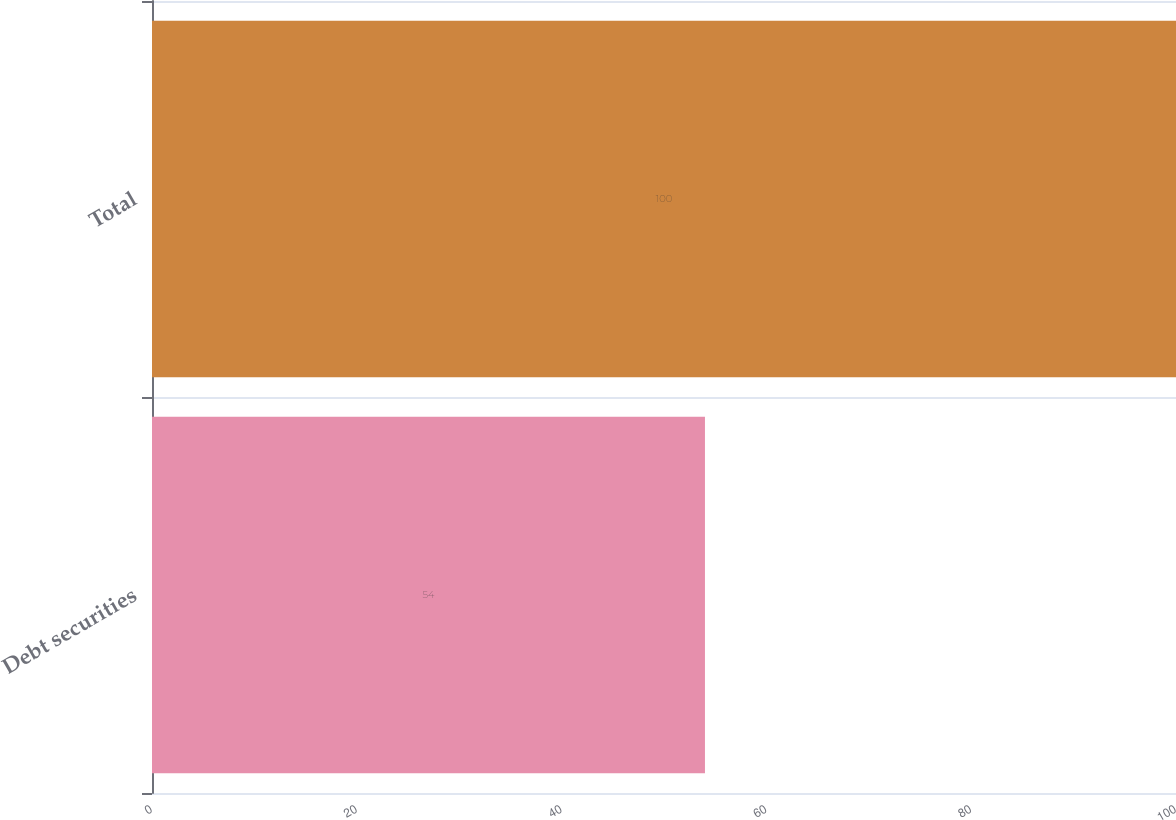<chart> <loc_0><loc_0><loc_500><loc_500><bar_chart><fcel>Debt securities<fcel>Total<nl><fcel>54<fcel>100<nl></chart> 